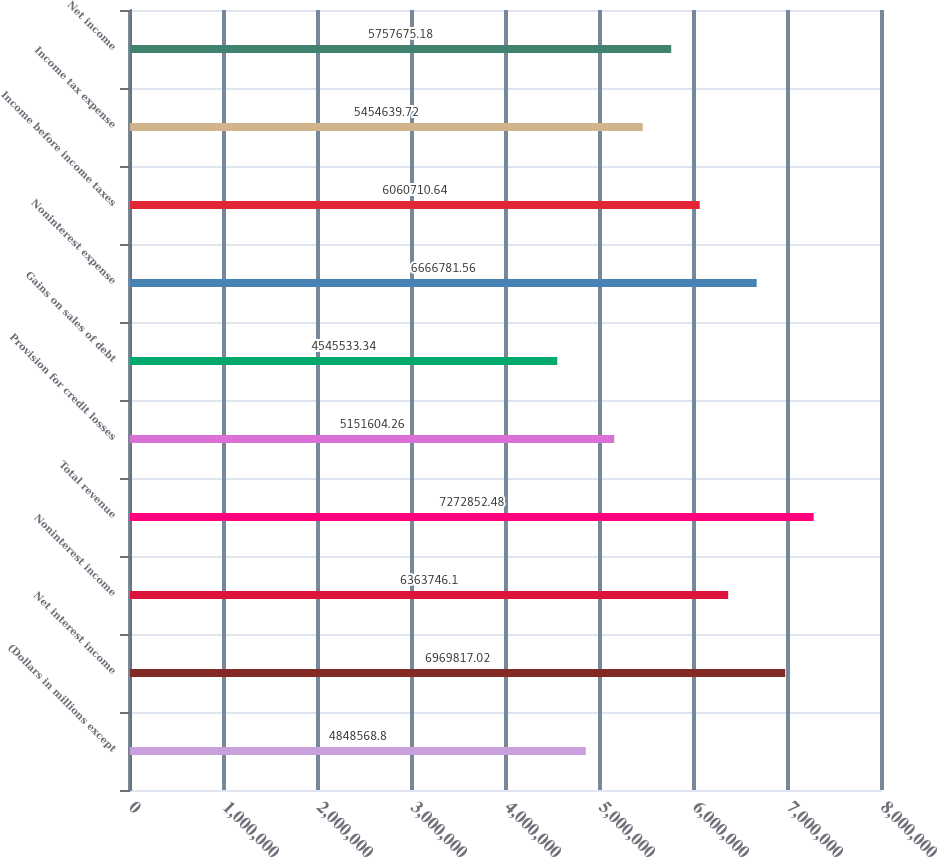Convert chart. <chart><loc_0><loc_0><loc_500><loc_500><bar_chart><fcel>(Dollars in millions except<fcel>Net interest income<fcel>Noninterest income<fcel>Total revenue<fcel>Provision for credit losses<fcel>Gains on sales of debt<fcel>Noninterest expense<fcel>Income before income taxes<fcel>Income tax expense<fcel>Net income<nl><fcel>4.84857e+06<fcel>6.96982e+06<fcel>6.36375e+06<fcel>7.27285e+06<fcel>5.1516e+06<fcel>4.54553e+06<fcel>6.66678e+06<fcel>6.06071e+06<fcel>5.45464e+06<fcel>5.75768e+06<nl></chart> 